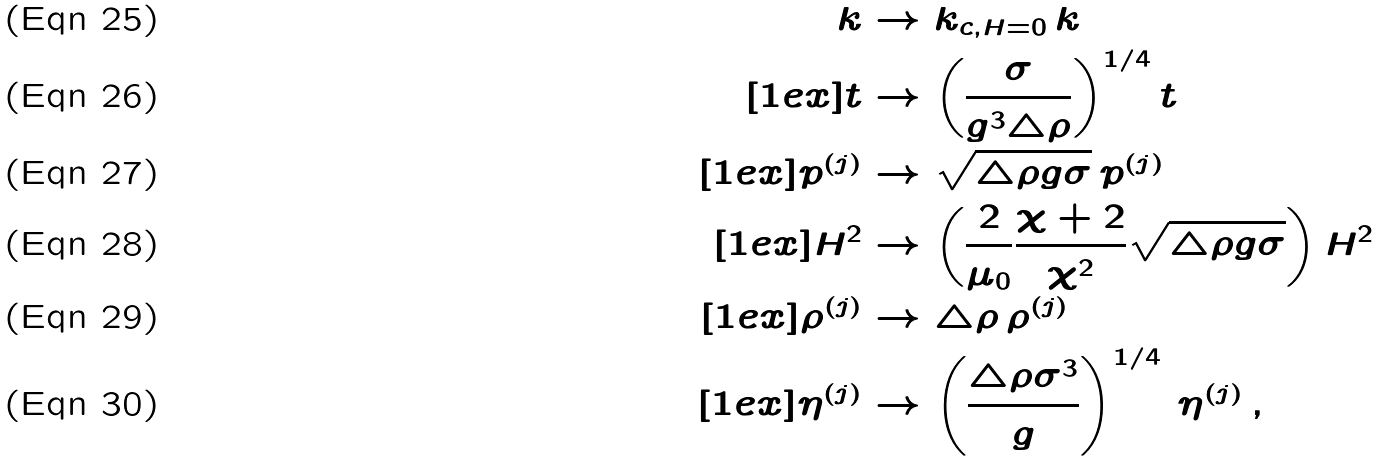<formula> <loc_0><loc_0><loc_500><loc_500>k & \rightarrow k _ { c , H = 0 } \, k \\ [ 1 e x ] t & \rightarrow \left ( \frac { \sigma } { g ^ { 3 } \triangle \rho } \right ) ^ { 1 / 4 } t \\ [ 1 e x ] p ^ { ( j ) } & \rightarrow \sqrt { \triangle \rho g \sigma } \, p ^ { ( j ) } \\ [ 1 e x ] H ^ { 2 } & \rightarrow \left ( \frac { 2 } { \mu _ { 0 } } \frac { \chi + 2 } { \chi ^ { 2 } } \sqrt { \triangle \rho g \sigma } \right ) H ^ { 2 } \\ [ 1 e x ] \rho ^ { ( j ) } & \rightarrow \triangle \rho \, \rho ^ { ( j ) } \\ [ 1 e x ] \eta ^ { ( j ) } & \rightarrow \left ( \frac { \triangle \rho \sigma ^ { 3 } } { g } \right ) ^ { 1 / 4 } \, \eta ^ { ( j ) } \, ,</formula> 